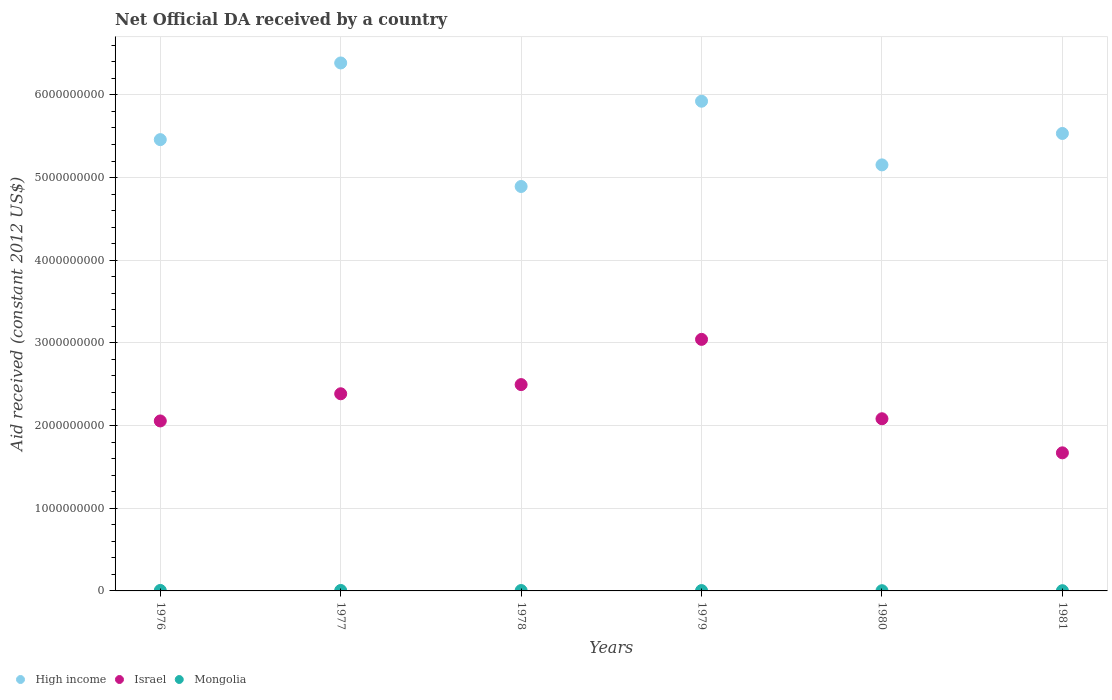How many different coloured dotlines are there?
Your answer should be very brief. 3. Is the number of dotlines equal to the number of legend labels?
Your response must be concise. Yes. What is the net official development assistance aid received in Mongolia in 1978?
Offer a very short reply. 4.73e+06. Across all years, what is the maximum net official development assistance aid received in High income?
Give a very brief answer. 6.39e+09. Across all years, what is the minimum net official development assistance aid received in High income?
Provide a succinct answer. 4.89e+09. In which year was the net official development assistance aid received in Mongolia maximum?
Keep it short and to the point. 1976. What is the total net official development assistance aid received in High income in the graph?
Offer a very short reply. 3.33e+1. What is the difference between the net official development assistance aid received in Israel in 1977 and that in 1978?
Ensure brevity in your answer.  -1.11e+08. What is the difference between the net official development assistance aid received in High income in 1976 and the net official development assistance aid received in Israel in 1980?
Provide a short and direct response. 3.38e+09. What is the average net official development assistance aid received in High income per year?
Your answer should be compact. 5.56e+09. In the year 1981, what is the difference between the net official development assistance aid received in High income and net official development assistance aid received in Mongolia?
Make the answer very short. 5.53e+09. What is the ratio of the net official development assistance aid received in Mongolia in 1978 to that in 1981?
Offer a terse response. 1.71. What is the difference between the highest and the second highest net official development assistance aid received in Israel?
Keep it short and to the point. 5.47e+08. What is the difference between the highest and the lowest net official development assistance aid received in Israel?
Your answer should be very brief. 1.37e+09. How many dotlines are there?
Provide a succinct answer. 3. What is the difference between two consecutive major ticks on the Y-axis?
Make the answer very short. 1.00e+09. How many legend labels are there?
Give a very brief answer. 3. How are the legend labels stacked?
Provide a succinct answer. Horizontal. What is the title of the graph?
Keep it short and to the point. Net Official DA received by a country. Does "Caribbean small states" appear as one of the legend labels in the graph?
Make the answer very short. No. What is the label or title of the Y-axis?
Your answer should be very brief. Aid received (constant 2012 US$). What is the Aid received (constant 2012 US$) of High income in 1976?
Keep it short and to the point. 5.46e+09. What is the Aid received (constant 2012 US$) of Israel in 1976?
Make the answer very short. 2.06e+09. What is the Aid received (constant 2012 US$) of Mongolia in 1976?
Offer a terse response. 5.86e+06. What is the Aid received (constant 2012 US$) in High income in 1977?
Keep it short and to the point. 6.39e+09. What is the Aid received (constant 2012 US$) in Israel in 1977?
Make the answer very short. 2.38e+09. What is the Aid received (constant 2012 US$) of Mongolia in 1977?
Offer a very short reply. 5.42e+06. What is the Aid received (constant 2012 US$) in High income in 1978?
Make the answer very short. 4.89e+09. What is the Aid received (constant 2012 US$) in Israel in 1978?
Make the answer very short. 2.50e+09. What is the Aid received (constant 2012 US$) of Mongolia in 1978?
Keep it short and to the point. 4.73e+06. What is the Aid received (constant 2012 US$) of High income in 1979?
Provide a succinct answer. 5.92e+09. What is the Aid received (constant 2012 US$) in Israel in 1979?
Your answer should be compact. 3.04e+09. What is the Aid received (constant 2012 US$) in Mongolia in 1979?
Provide a short and direct response. 4.25e+06. What is the Aid received (constant 2012 US$) in High income in 1980?
Your response must be concise. 5.15e+09. What is the Aid received (constant 2012 US$) of Israel in 1980?
Offer a terse response. 2.08e+09. What is the Aid received (constant 2012 US$) of Mongolia in 1980?
Offer a very short reply. 2.67e+06. What is the Aid received (constant 2012 US$) in High income in 1981?
Your answer should be very brief. 5.53e+09. What is the Aid received (constant 2012 US$) of Israel in 1981?
Your answer should be compact. 1.67e+09. What is the Aid received (constant 2012 US$) in Mongolia in 1981?
Make the answer very short. 2.77e+06. Across all years, what is the maximum Aid received (constant 2012 US$) in High income?
Offer a very short reply. 6.39e+09. Across all years, what is the maximum Aid received (constant 2012 US$) of Israel?
Ensure brevity in your answer.  3.04e+09. Across all years, what is the maximum Aid received (constant 2012 US$) of Mongolia?
Your answer should be compact. 5.86e+06. Across all years, what is the minimum Aid received (constant 2012 US$) of High income?
Give a very brief answer. 4.89e+09. Across all years, what is the minimum Aid received (constant 2012 US$) of Israel?
Your answer should be very brief. 1.67e+09. Across all years, what is the minimum Aid received (constant 2012 US$) of Mongolia?
Keep it short and to the point. 2.67e+06. What is the total Aid received (constant 2012 US$) of High income in the graph?
Your response must be concise. 3.33e+1. What is the total Aid received (constant 2012 US$) in Israel in the graph?
Ensure brevity in your answer.  1.37e+1. What is the total Aid received (constant 2012 US$) in Mongolia in the graph?
Provide a succinct answer. 2.57e+07. What is the difference between the Aid received (constant 2012 US$) of High income in 1976 and that in 1977?
Provide a succinct answer. -9.27e+08. What is the difference between the Aid received (constant 2012 US$) in Israel in 1976 and that in 1977?
Your response must be concise. -3.29e+08. What is the difference between the Aid received (constant 2012 US$) in Mongolia in 1976 and that in 1977?
Ensure brevity in your answer.  4.40e+05. What is the difference between the Aid received (constant 2012 US$) of High income in 1976 and that in 1978?
Your response must be concise. 5.67e+08. What is the difference between the Aid received (constant 2012 US$) in Israel in 1976 and that in 1978?
Provide a succinct answer. -4.40e+08. What is the difference between the Aid received (constant 2012 US$) in Mongolia in 1976 and that in 1978?
Give a very brief answer. 1.13e+06. What is the difference between the Aid received (constant 2012 US$) of High income in 1976 and that in 1979?
Give a very brief answer. -4.65e+08. What is the difference between the Aid received (constant 2012 US$) of Israel in 1976 and that in 1979?
Your answer should be very brief. -9.87e+08. What is the difference between the Aid received (constant 2012 US$) in Mongolia in 1976 and that in 1979?
Offer a very short reply. 1.61e+06. What is the difference between the Aid received (constant 2012 US$) in High income in 1976 and that in 1980?
Give a very brief answer. 3.05e+08. What is the difference between the Aid received (constant 2012 US$) of Israel in 1976 and that in 1980?
Keep it short and to the point. -2.65e+07. What is the difference between the Aid received (constant 2012 US$) in Mongolia in 1976 and that in 1980?
Ensure brevity in your answer.  3.19e+06. What is the difference between the Aid received (constant 2012 US$) in High income in 1976 and that in 1981?
Your response must be concise. -7.44e+07. What is the difference between the Aid received (constant 2012 US$) of Israel in 1976 and that in 1981?
Offer a very short reply. 3.86e+08. What is the difference between the Aid received (constant 2012 US$) of Mongolia in 1976 and that in 1981?
Your response must be concise. 3.09e+06. What is the difference between the Aid received (constant 2012 US$) of High income in 1977 and that in 1978?
Provide a succinct answer. 1.49e+09. What is the difference between the Aid received (constant 2012 US$) in Israel in 1977 and that in 1978?
Make the answer very short. -1.11e+08. What is the difference between the Aid received (constant 2012 US$) of Mongolia in 1977 and that in 1978?
Provide a short and direct response. 6.90e+05. What is the difference between the Aid received (constant 2012 US$) of High income in 1977 and that in 1979?
Offer a terse response. 4.63e+08. What is the difference between the Aid received (constant 2012 US$) in Israel in 1977 and that in 1979?
Make the answer very short. -6.58e+08. What is the difference between the Aid received (constant 2012 US$) in Mongolia in 1977 and that in 1979?
Your answer should be very brief. 1.17e+06. What is the difference between the Aid received (constant 2012 US$) in High income in 1977 and that in 1980?
Offer a very short reply. 1.23e+09. What is the difference between the Aid received (constant 2012 US$) of Israel in 1977 and that in 1980?
Keep it short and to the point. 3.02e+08. What is the difference between the Aid received (constant 2012 US$) of Mongolia in 1977 and that in 1980?
Your response must be concise. 2.75e+06. What is the difference between the Aid received (constant 2012 US$) of High income in 1977 and that in 1981?
Your response must be concise. 8.53e+08. What is the difference between the Aid received (constant 2012 US$) in Israel in 1977 and that in 1981?
Ensure brevity in your answer.  7.14e+08. What is the difference between the Aid received (constant 2012 US$) in Mongolia in 1977 and that in 1981?
Your response must be concise. 2.65e+06. What is the difference between the Aid received (constant 2012 US$) of High income in 1978 and that in 1979?
Your response must be concise. -1.03e+09. What is the difference between the Aid received (constant 2012 US$) in Israel in 1978 and that in 1979?
Keep it short and to the point. -5.47e+08. What is the difference between the Aid received (constant 2012 US$) in Mongolia in 1978 and that in 1979?
Provide a succinct answer. 4.80e+05. What is the difference between the Aid received (constant 2012 US$) of High income in 1978 and that in 1980?
Provide a short and direct response. -2.61e+08. What is the difference between the Aid received (constant 2012 US$) of Israel in 1978 and that in 1980?
Provide a short and direct response. 4.13e+08. What is the difference between the Aid received (constant 2012 US$) of Mongolia in 1978 and that in 1980?
Your answer should be compact. 2.06e+06. What is the difference between the Aid received (constant 2012 US$) in High income in 1978 and that in 1981?
Your answer should be compact. -6.41e+08. What is the difference between the Aid received (constant 2012 US$) in Israel in 1978 and that in 1981?
Offer a very short reply. 8.25e+08. What is the difference between the Aid received (constant 2012 US$) in Mongolia in 1978 and that in 1981?
Provide a short and direct response. 1.96e+06. What is the difference between the Aid received (constant 2012 US$) of High income in 1979 and that in 1980?
Make the answer very short. 7.70e+08. What is the difference between the Aid received (constant 2012 US$) of Israel in 1979 and that in 1980?
Provide a succinct answer. 9.60e+08. What is the difference between the Aid received (constant 2012 US$) of Mongolia in 1979 and that in 1980?
Provide a short and direct response. 1.58e+06. What is the difference between the Aid received (constant 2012 US$) of High income in 1979 and that in 1981?
Give a very brief answer. 3.90e+08. What is the difference between the Aid received (constant 2012 US$) of Israel in 1979 and that in 1981?
Give a very brief answer. 1.37e+09. What is the difference between the Aid received (constant 2012 US$) in Mongolia in 1979 and that in 1981?
Your answer should be compact. 1.48e+06. What is the difference between the Aid received (constant 2012 US$) in High income in 1980 and that in 1981?
Ensure brevity in your answer.  -3.80e+08. What is the difference between the Aid received (constant 2012 US$) of Israel in 1980 and that in 1981?
Your answer should be very brief. 4.12e+08. What is the difference between the Aid received (constant 2012 US$) of High income in 1976 and the Aid received (constant 2012 US$) of Israel in 1977?
Your answer should be very brief. 3.07e+09. What is the difference between the Aid received (constant 2012 US$) of High income in 1976 and the Aid received (constant 2012 US$) of Mongolia in 1977?
Keep it short and to the point. 5.45e+09. What is the difference between the Aid received (constant 2012 US$) in Israel in 1976 and the Aid received (constant 2012 US$) in Mongolia in 1977?
Offer a very short reply. 2.05e+09. What is the difference between the Aid received (constant 2012 US$) in High income in 1976 and the Aid received (constant 2012 US$) in Israel in 1978?
Ensure brevity in your answer.  2.96e+09. What is the difference between the Aid received (constant 2012 US$) in High income in 1976 and the Aid received (constant 2012 US$) in Mongolia in 1978?
Your answer should be very brief. 5.45e+09. What is the difference between the Aid received (constant 2012 US$) of Israel in 1976 and the Aid received (constant 2012 US$) of Mongolia in 1978?
Ensure brevity in your answer.  2.05e+09. What is the difference between the Aid received (constant 2012 US$) of High income in 1976 and the Aid received (constant 2012 US$) of Israel in 1979?
Make the answer very short. 2.42e+09. What is the difference between the Aid received (constant 2012 US$) of High income in 1976 and the Aid received (constant 2012 US$) of Mongolia in 1979?
Offer a very short reply. 5.45e+09. What is the difference between the Aid received (constant 2012 US$) of Israel in 1976 and the Aid received (constant 2012 US$) of Mongolia in 1979?
Offer a terse response. 2.05e+09. What is the difference between the Aid received (constant 2012 US$) of High income in 1976 and the Aid received (constant 2012 US$) of Israel in 1980?
Make the answer very short. 3.38e+09. What is the difference between the Aid received (constant 2012 US$) in High income in 1976 and the Aid received (constant 2012 US$) in Mongolia in 1980?
Offer a terse response. 5.46e+09. What is the difference between the Aid received (constant 2012 US$) of Israel in 1976 and the Aid received (constant 2012 US$) of Mongolia in 1980?
Offer a very short reply. 2.05e+09. What is the difference between the Aid received (constant 2012 US$) in High income in 1976 and the Aid received (constant 2012 US$) in Israel in 1981?
Your response must be concise. 3.79e+09. What is the difference between the Aid received (constant 2012 US$) in High income in 1976 and the Aid received (constant 2012 US$) in Mongolia in 1981?
Provide a succinct answer. 5.46e+09. What is the difference between the Aid received (constant 2012 US$) in Israel in 1976 and the Aid received (constant 2012 US$) in Mongolia in 1981?
Your response must be concise. 2.05e+09. What is the difference between the Aid received (constant 2012 US$) in High income in 1977 and the Aid received (constant 2012 US$) in Israel in 1978?
Ensure brevity in your answer.  3.89e+09. What is the difference between the Aid received (constant 2012 US$) of High income in 1977 and the Aid received (constant 2012 US$) of Mongolia in 1978?
Your response must be concise. 6.38e+09. What is the difference between the Aid received (constant 2012 US$) of Israel in 1977 and the Aid received (constant 2012 US$) of Mongolia in 1978?
Ensure brevity in your answer.  2.38e+09. What is the difference between the Aid received (constant 2012 US$) in High income in 1977 and the Aid received (constant 2012 US$) in Israel in 1979?
Make the answer very short. 3.34e+09. What is the difference between the Aid received (constant 2012 US$) in High income in 1977 and the Aid received (constant 2012 US$) in Mongolia in 1979?
Offer a very short reply. 6.38e+09. What is the difference between the Aid received (constant 2012 US$) of Israel in 1977 and the Aid received (constant 2012 US$) of Mongolia in 1979?
Offer a very short reply. 2.38e+09. What is the difference between the Aid received (constant 2012 US$) in High income in 1977 and the Aid received (constant 2012 US$) in Israel in 1980?
Your answer should be very brief. 4.30e+09. What is the difference between the Aid received (constant 2012 US$) of High income in 1977 and the Aid received (constant 2012 US$) of Mongolia in 1980?
Ensure brevity in your answer.  6.38e+09. What is the difference between the Aid received (constant 2012 US$) of Israel in 1977 and the Aid received (constant 2012 US$) of Mongolia in 1980?
Offer a very short reply. 2.38e+09. What is the difference between the Aid received (constant 2012 US$) of High income in 1977 and the Aid received (constant 2012 US$) of Israel in 1981?
Your answer should be very brief. 4.72e+09. What is the difference between the Aid received (constant 2012 US$) of High income in 1977 and the Aid received (constant 2012 US$) of Mongolia in 1981?
Your response must be concise. 6.38e+09. What is the difference between the Aid received (constant 2012 US$) in Israel in 1977 and the Aid received (constant 2012 US$) in Mongolia in 1981?
Provide a succinct answer. 2.38e+09. What is the difference between the Aid received (constant 2012 US$) of High income in 1978 and the Aid received (constant 2012 US$) of Israel in 1979?
Your response must be concise. 1.85e+09. What is the difference between the Aid received (constant 2012 US$) of High income in 1978 and the Aid received (constant 2012 US$) of Mongolia in 1979?
Provide a succinct answer. 4.89e+09. What is the difference between the Aid received (constant 2012 US$) in Israel in 1978 and the Aid received (constant 2012 US$) in Mongolia in 1979?
Provide a short and direct response. 2.49e+09. What is the difference between the Aid received (constant 2012 US$) of High income in 1978 and the Aid received (constant 2012 US$) of Israel in 1980?
Provide a short and direct response. 2.81e+09. What is the difference between the Aid received (constant 2012 US$) in High income in 1978 and the Aid received (constant 2012 US$) in Mongolia in 1980?
Make the answer very short. 4.89e+09. What is the difference between the Aid received (constant 2012 US$) in Israel in 1978 and the Aid received (constant 2012 US$) in Mongolia in 1980?
Provide a succinct answer. 2.49e+09. What is the difference between the Aid received (constant 2012 US$) of High income in 1978 and the Aid received (constant 2012 US$) of Israel in 1981?
Offer a terse response. 3.22e+09. What is the difference between the Aid received (constant 2012 US$) in High income in 1978 and the Aid received (constant 2012 US$) in Mongolia in 1981?
Your answer should be compact. 4.89e+09. What is the difference between the Aid received (constant 2012 US$) in Israel in 1978 and the Aid received (constant 2012 US$) in Mongolia in 1981?
Make the answer very short. 2.49e+09. What is the difference between the Aid received (constant 2012 US$) of High income in 1979 and the Aid received (constant 2012 US$) of Israel in 1980?
Your response must be concise. 3.84e+09. What is the difference between the Aid received (constant 2012 US$) of High income in 1979 and the Aid received (constant 2012 US$) of Mongolia in 1980?
Your answer should be very brief. 5.92e+09. What is the difference between the Aid received (constant 2012 US$) in Israel in 1979 and the Aid received (constant 2012 US$) in Mongolia in 1980?
Your answer should be very brief. 3.04e+09. What is the difference between the Aid received (constant 2012 US$) of High income in 1979 and the Aid received (constant 2012 US$) of Israel in 1981?
Offer a terse response. 4.25e+09. What is the difference between the Aid received (constant 2012 US$) in High income in 1979 and the Aid received (constant 2012 US$) in Mongolia in 1981?
Keep it short and to the point. 5.92e+09. What is the difference between the Aid received (constant 2012 US$) in Israel in 1979 and the Aid received (constant 2012 US$) in Mongolia in 1981?
Your answer should be compact. 3.04e+09. What is the difference between the Aid received (constant 2012 US$) in High income in 1980 and the Aid received (constant 2012 US$) in Israel in 1981?
Offer a very short reply. 3.48e+09. What is the difference between the Aid received (constant 2012 US$) in High income in 1980 and the Aid received (constant 2012 US$) in Mongolia in 1981?
Offer a very short reply. 5.15e+09. What is the difference between the Aid received (constant 2012 US$) in Israel in 1980 and the Aid received (constant 2012 US$) in Mongolia in 1981?
Offer a very short reply. 2.08e+09. What is the average Aid received (constant 2012 US$) in High income per year?
Your answer should be compact. 5.56e+09. What is the average Aid received (constant 2012 US$) of Israel per year?
Provide a short and direct response. 2.29e+09. What is the average Aid received (constant 2012 US$) of Mongolia per year?
Ensure brevity in your answer.  4.28e+06. In the year 1976, what is the difference between the Aid received (constant 2012 US$) in High income and Aid received (constant 2012 US$) in Israel?
Ensure brevity in your answer.  3.40e+09. In the year 1976, what is the difference between the Aid received (constant 2012 US$) of High income and Aid received (constant 2012 US$) of Mongolia?
Your response must be concise. 5.45e+09. In the year 1976, what is the difference between the Aid received (constant 2012 US$) of Israel and Aid received (constant 2012 US$) of Mongolia?
Give a very brief answer. 2.05e+09. In the year 1977, what is the difference between the Aid received (constant 2012 US$) of High income and Aid received (constant 2012 US$) of Israel?
Your answer should be compact. 4.00e+09. In the year 1977, what is the difference between the Aid received (constant 2012 US$) of High income and Aid received (constant 2012 US$) of Mongolia?
Make the answer very short. 6.38e+09. In the year 1977, what is the difference between the Aid received (constant 2012 US$) of Israel and Aid received (constant 2012 US$) of Mongolia?
Provide a short and direct response. 2.38e+09. In the year 1978, what is the difference between the Aid received (constant 2012 US$) in High income and Aid received (constant 2012 US$) in Israel?
Ensure brevity in your answer.  2.40e+09. In the year 1978, what is the difference between the Aid received (constant 2012 US$) in High income and Aid received (constant 2012 US$) in Mongolia?
Make the answer very short. 4.89e+09. In the year 1978, what is the difference between the Aid received (constant 2012 US$) of Israel and Aid received (constant 2012 US$) of Mongolia?
Ensure brevity in your answer.  2.49e+09. In the year 1979, what is the difference between the Aid received (constant 2012 US$) of High income and Aid received (constant 2012 US$) of Israel?
Make the answer very short. 2.88e+09. In the year 1979, what is the difference between the Aid received (constant 2012 US$) in High income and Aid received (constant 2012 US$) in Mongolia?
Give a very brief answer. 5.92e+09. In the year 1979, what is the difference between the Aid received (constant 2012 US$) of Israel and Aid received (constant 2012 US$) of Mongolia?
Make the answer very short. 3.04e+09. In the year 1980, what is the difference between the Aid received (constant 2012 US$) of High income and Aid received (constant 2012 US$) of Israel?
Offer a very short reply. 3.07e+09. In the year 1980, what is the difference between the Aid received (constant 2012 US$) in High income and Aid received (constant 2012 US$) in Mongolia?
Keep it short and to the point. 5.15e+09. In the year 1980, what is the difference between the Aid received (constant 2012 US$) in Israel and Aid received (constant 2012 US$) in Mongolia?
Ensure brevity in your answer.  2.08e+09. In the year 1981, what is the difference between the Aid received (constant 2012 US$) in High income and Aid received (constant 2012 US$) in Israel?
Ensure brevity in your answer.  3.86e+09. In the year 1981, what is the difference between the Aid received (constant 2012 US$) of High income and Aid received (constant 2012 US$) of Mongolia?
Keep it short and to the point. 5.53e+09. In the year 1981, what is the difference between the Aid received (constant 2012 US$) in Israel and Aid received (constant 2012 US$) in Mongolia?
Provide a short and direct response. 1.67e+09. What is the ratio of the Aid received (constant 2012 US$) of High income in 1976 to that in 1977?
Keep it short and to the point. 0.85. What is the ratio of the Aid received (constant 2012 US$) of Israel in 1976 to that in 1977?
Your response must be concise. 0.86. What is the ratio of the Aid received (constant 2012 US$) of Mongolia in 1976 to that in 1977?
Keep it short and to the point. 1.08. What is the ratio of the Aid received (constant 2012 US$) in High income in 1976 to that in 1978?
Your answer should be very brief. 1.12. What is the ratio of the Aid received (constant 2012 US$) of Israel in 1976 to that in 1978?
Your response must be concise. 0.82. What is the ratio of the Aid received (constant 2012 US$) of Mongolia in 1976 to that in 1978?
Ensure brevity in your answer.  1.24. What is the ratio of the Aid received (constant 2012 US$) in High income in 1976 to that in 1979?
Provide a short and direct response. 0.92. What is the ratio of the Aid received (constant 2012 US$) in Israel in 1976 to that in 1979?
Your response must be concise. 0.68. What is the ratio of the Aid received (constant 2012 US$) of Mongolia in 1976 to that in 1979?
Your response must be concise. 1.38. What is the ratio of the Aid received (constant 2012 US$) in High income in 1976 to that in 1980?
Your response must be concise. 1.06. What is the ratio of the Aid received (constant 2012 US$) in Israel in 1976 to that in 1980?
Make the answer very short. 0.99. What is the ratio of the Aid received (constant 2012 US$) in Mongolia in 1976 to that in 1980?
Provide a short and direct response. 2.19. What is the ratio of the Aid received (constant 2012 US$) of High income in 1976 to that in 1981?
Give a very brief answer. 0.99. What is the ratio of the Aid received (constant 2012 US$) in Israel in 1976 to that in 1981?
Your response must be concise. 1.23. What is the ratio of the Aid received (constant 2012 US$) in Mongolia in 1976 to that in 1981?
Your answer should be very brief. 2.12. What is the ratio of the Aid received (constant 2012 US$) in High income in 1977 to that in 1978?
Offer a terse response. 1.31. What is the ratio of the Aid received (constant 2012 US$) in Israel in 1977 to that in 1978?
Your response must be concise. 0.96. What is the ratio of the Aid received (constant 2012 US$) of Mongolia in 1977 to that in 1978?
Keep it short and to the point. 1.15. What is the ratio of the Aid received (constant 2012 US$) in High income in 1977 to that in 1979?
Give a very brief answer. 1.08. What is the ratio of the Aid received (constant 2012 US$) of Israel in 1977 to that in 1979?
Your answer should be compact. 0.78. What is the ratio of the Aid received (constant 2012 US$) in Mongolia in 1977 to that in 1979?
Ensure brevity in your answer.  1.28. What is the ratio of the Aid received (constant 2012 US$) of High income in 1977 to that in 1980?
Offer a very short reply. 1.24. What is the ratio of the Aid received (constant 2012 US$) in Israel in 1977 to that in 1980?
Offer a terse response. 1.15. What is the ratio of the Aid received (constant 2012 US$) in Mongolia in 1977 to that in 1980?
Your response must be concise. 2.03. What is the ratio of the Aid received (constant 2012 US$) of High income in 1977 to that in 1981?
Your answer should be compact. 1.15. What is the ratio of the Aid received (constant 2012 US$) of Israel in 1977 to that in 1981?
Your answer should be compact. 1.43. What is the ratio of the Aid received (constant 2012 US$) in Mongolia in 1977 to that in 1981?
Offer a very short reply. 1.96. What is the ratio of the Aid received (constant 2012 US$) of High income in 1978 to that in 1979?
Offer a very short reply. 0.83. What is the ratio of the Aid received (constant 2012 US$) in Israel in 1978 to that in 1979?
Provide a succinct answer. 0.82. What is the ratio of the Aid received (constant 2012 US$) of Mongolia in 1978 to that in 1979?
Provide a succinct answer. 1.11. What is the ratio of the Aid received (constant 2012 US$) in High income in 1978 to that in 1980?
Your response must be concise. 0.95. What is the ratio of the Aid received (constant 2012 US$) in Israel in 1978 to that in 1980?
Provide a short and direct response. 1.2. What is the ratio of the Aid received (constant 2012 US$) of Mongolia in 1978 to that in 1980?
Give a very brief answer. 1.77. What is the ratio of the Aid received (constant 2012 US$) in High income in 1978 to that in 1981?
Offer a very short reply. 0.88. What is the ratio of the Aid received (constant 2012 US$) of Israel in 1978 to that in 1981?
Your response must be concise. 1.49. What is the ratio of the Aid received (constant 2012 US$) of Mongolia in 1978 to that in 1981?
Keep it short and to the point. 1.71. What is the ratio of the Aid received (constant 2012 US$) of High income in 1979 to that in 1980?
Keep it short and to the point. 1.15. What is the ratio of the Aid received (constant 2012 US$) of Israel in 1979 to that in 1980?
Provide a succinct answer. 1.46. What is the ratio of the Aid received (constant 2012 US$) of Mongolia in 1979 to that in 1980?
Give a very brief answer. 1.59. What is the ratio of the Aid received (constant 2012 US$) in High income in 1979 to that in 1981?
Your answer should be compact. 1.07. What is the ratio of the Aid received (constant 2012 US$) in Israel in 1979 to that in 1981?
Offer a very short reply. 1.82. What is the ratio of the Aid received (constant 2012 US$) in Mongolia in 1979 to that in 1981?
Offer a terse response. 1.53. What is the ratio of the Aid received (constant 2012 US$) of High income in 1980 to that in 1981?
Ensure brevity in your answer.  0.93. What is the ratio of the Aid received (constant 2012 US$) of Israel in 1980 to that in 1981?
Ensure brevity in your answer.  1.25. What is the ratio of the Aid received (constant 2012 US$) in Mongolia in 1980 to that in 1981?
Offer a terse response. 0.96. What is the difference between the highest and the second highest Aid received (constant 2012 US$) in High income?
Your response must be concise. 4.63e+08. What is the difference between the highest and the second highest Aid received (constant 2012 US$) of Israel?
Offer a terse response. 5.47e+08. What is the difference between the highest and the second highest Aid received (constant 2012 US$) of Mongolia?
Offer a terse response. 4.40e+05. What is the difference between the highest and the lowest Aid received (constant 2012 US$) of High income?
Give a very brief answer. 1.49e+09. What is the difference between the highest and the lowest Aid received (constant 2012 US$) in Israel?
Your response must be concise. 1.37e+09. What is the difference between the highest and the lowest Aid received (constant 2012 US$) in Mongolia?
Provide a succinct answer. 3.19e+06. 